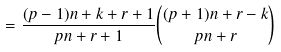<formula> <loc_0><loc_0><loc_500><loc_500>= \frac { ( p - 1 ) n + k + r + 1 } { p n + r + 1 } \binom { ( p + 1 ) n + r - k } { p n + r }</formula> 